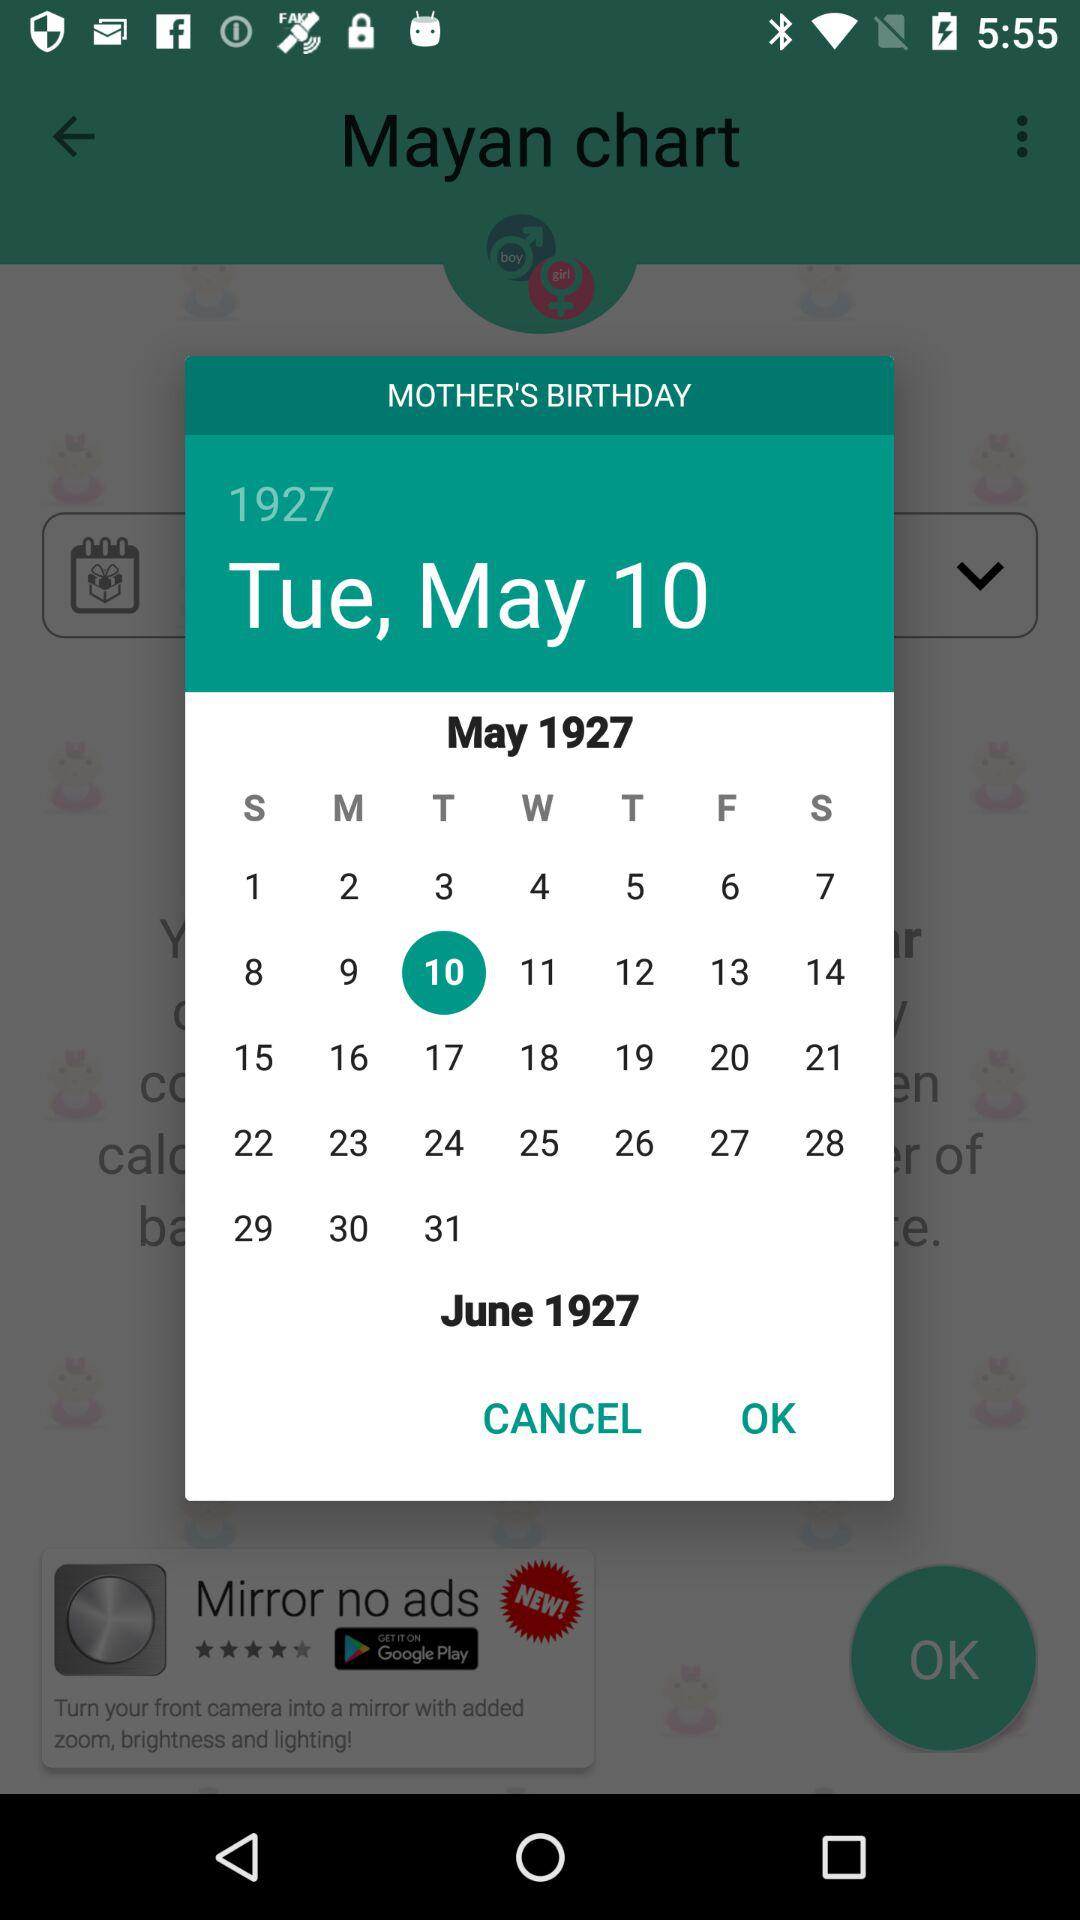Which gender is selected?
When the provided information is insufficient, respond with <no answer>. <no answer> 